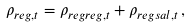<formula> <loc_0><loc_0><loc_500><loc_500>\rho _ { r e g , t } = \rho _ { r e g r e g , t } + \rho _ { r e g s a l , t } \, ,</formula> 